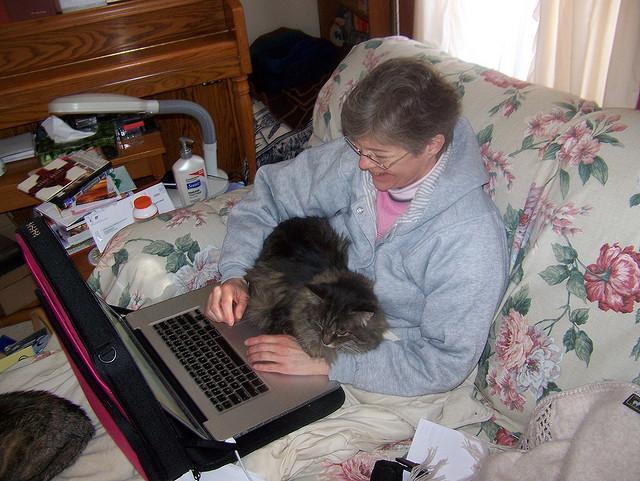Is "The person is touching the couch." an appropriate description for the image?
Answer yes or no. Yes. 